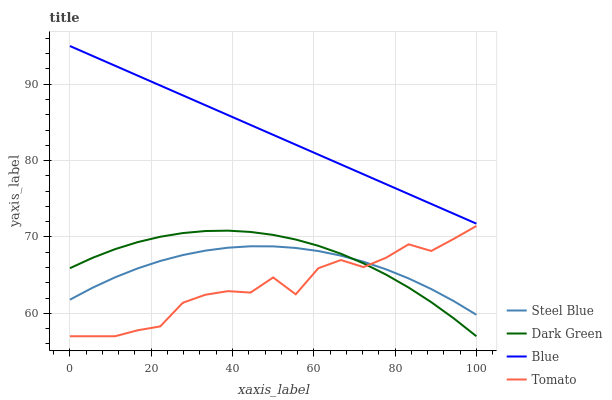Does Tomato have the minimum area under the curve?
Answer yes or no. Yes. Does Blue have the maximum area under the curve?
Answer yes or no. Yes. Does Steel Blue have the minimum area under the curve?
Answer yes or no. No. Does Steel Blue have the maximum area under the curve?
Answer yes or no. No. Is Blue the smoothest?
Answer yes or no. Yes. Is Tomato the roughest?
Answer yes or no. Yes. Is Steel Blue the smoothest?
Answer yes or no. No. Is Steel Blue the roughest?
Answer yes or no. No. Does Steel Blue have the lowest value?
Answer yes or no. No. Does Tomato have the highest value?
Answer yes or no. No. Is Steel Blue less than Blue?
Answer yes or no. Yes. Is Blue greater than Dark Green?
Answer yes or no. Yes. Does Steel Blue intersect Blue?
Answer yes or no. No. 